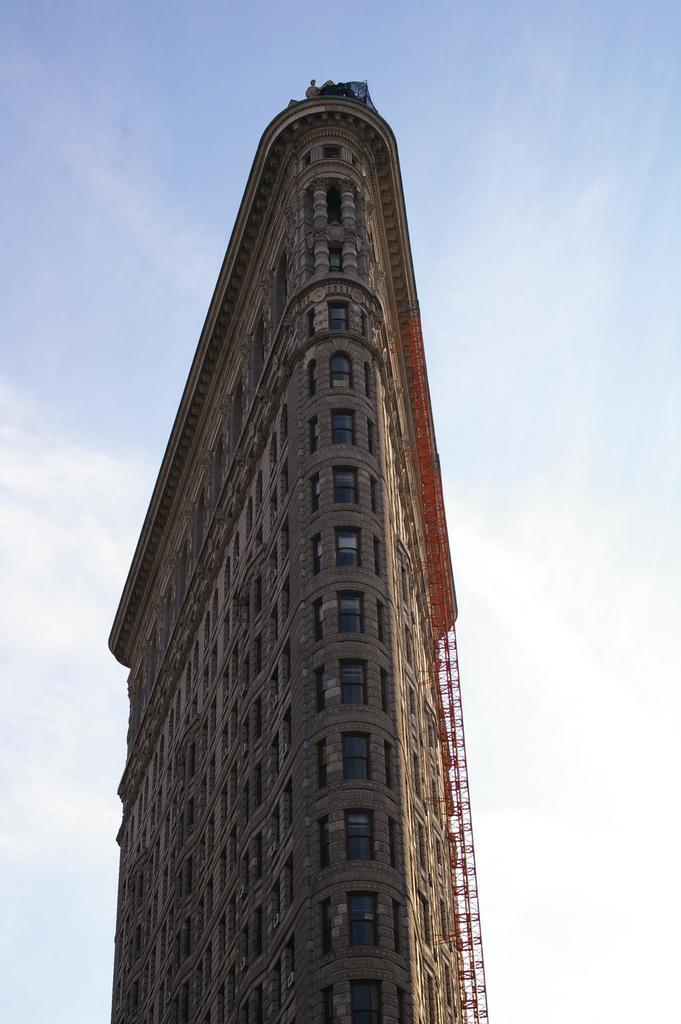What type of structure is present in the image? There is a building in the image. What colors can be seen on the building? The building has brown and black colors. Are there any openings on the building? Yes, there are windows on the building. What is the color of the sky in the image? The sky is blue and white in color. How many attempts were made to help the lumber in the image? There is no lumber or any indication of an attempt to help anything in the image. 